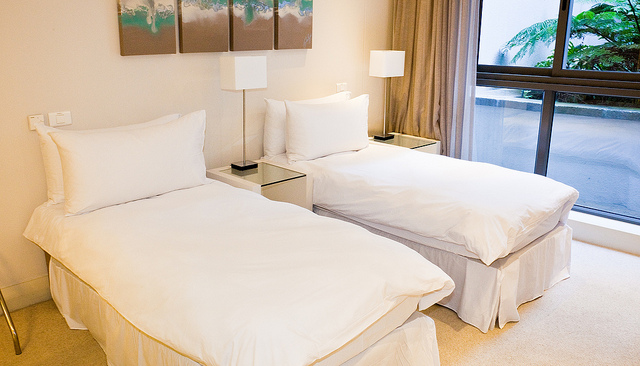How many beds are there? 2 